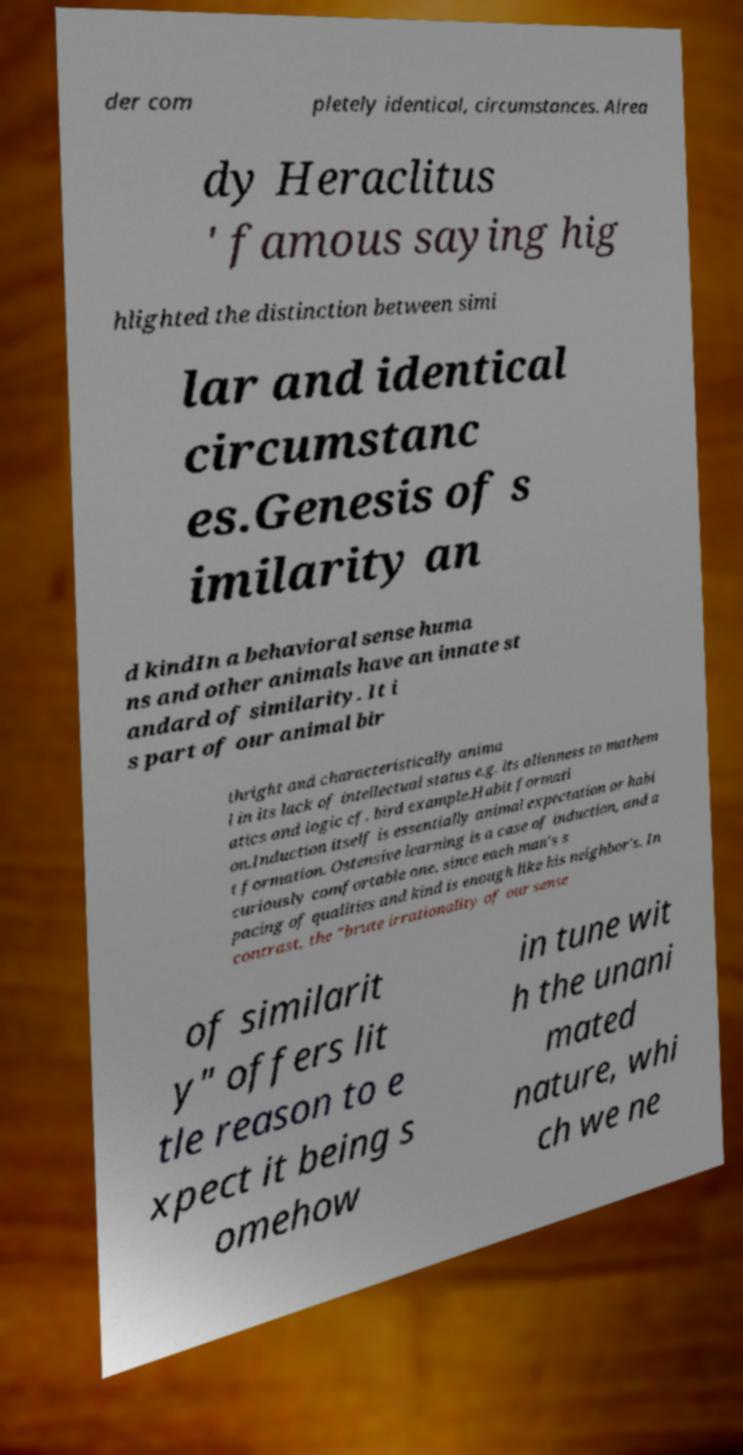What messages or text are displayed in this image? I need them in a readable, typed format. der com pletely identical, circumstances. Alrea dy Heraclitus ' famous saying hig hlighted the distinction between simi lar and identical circumstanc es.Genesis of s imilarity an d kindIn a behavioral sense huma ns and other animals have an innate st andard of similarity. It i s part of our animal bir thright and characteristically anima l in its lack of intellectual status e.g. its alienness to mathem atics and logic cf. bird example.Habit formati on.Induction itself is essentially animal expectation or habi t formation. Ostensive learning is a case of induction, and a curiously comfortable one, since each man's s pacing of qualities and kind is enough like his neighbor's. In contrast, the "brute irrationality of our sense of similarit y" offers lit tle reason to e xpect it being s omehow in tune wit h the unani mated nature, whi ch we ne 